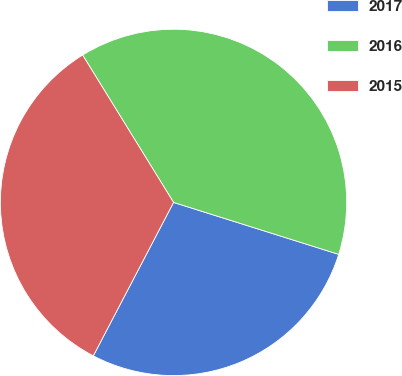Convert chart. <chart><loc_0><loc_0><loc_500><loc_500><pie_chart><fcel>2017<fcel>2016<fcel>2015<nl><fcel>27.82%<fcel>38.65%<fcel>33.53%<nl></chart> 